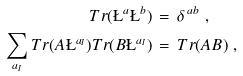<formula> <loc_0><loc_0><loc_500><loc_500>T r ( \L ^ { a } \L ^ { b } ) & \, = \, \delta ^ { \, a b } \ , \\ \sum _ { a _ { I } } T r ( A \L ^ { a _ { I } } ) T r ( B \L ^ { a _ { I } } ) & \, = \, T r ( A B ) \ ,</formula> 